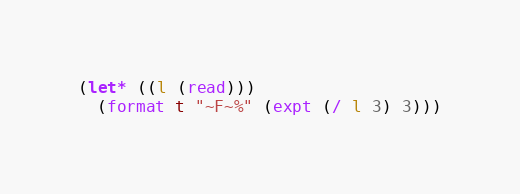<code> <loc_0><loc_0><loc_500><loc_500><_Lisp_>(let* ((l (read)))
  (format t "~F~%" (expt (/ l 3) 3)))
</code> 